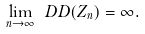<formula> <loc_0><loc_0><loc_500><loc_500>\lim _ { n \rightarrow \infty } \ D D ( Z _ { n } ) = \infty .</formula> 